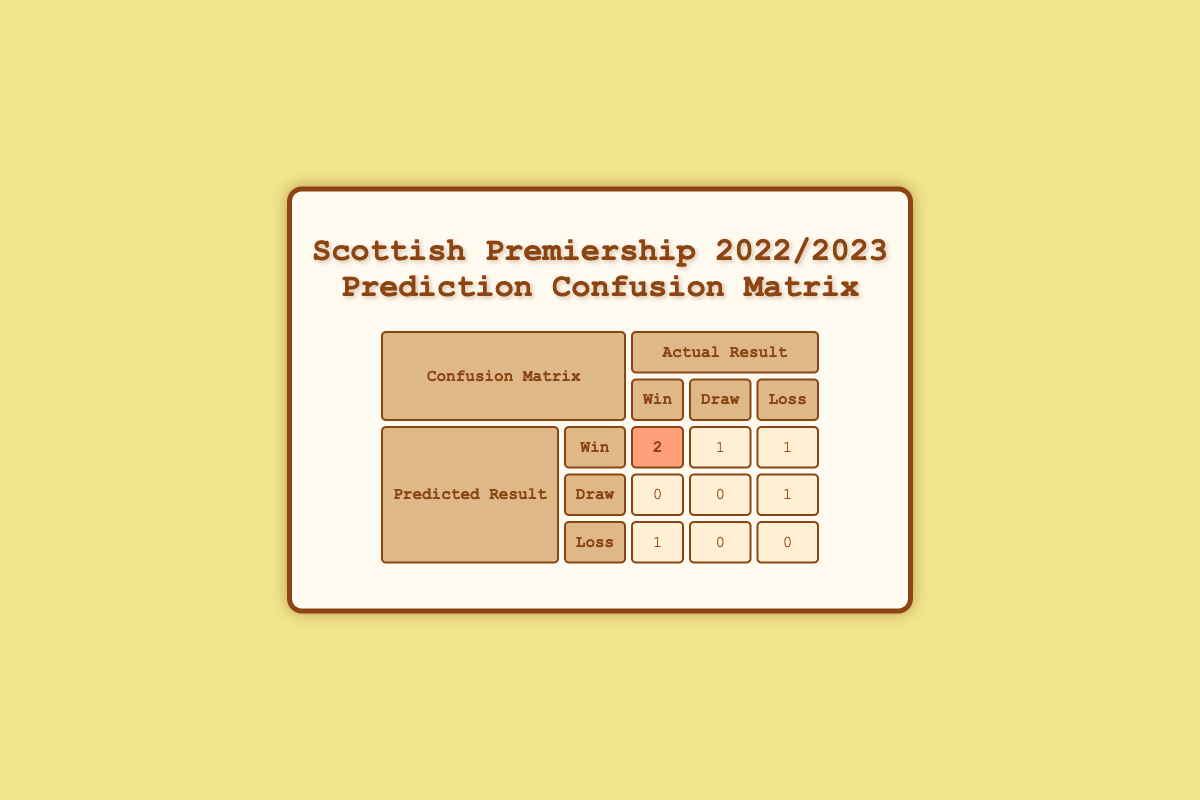What is the predicted result when the actual result was a Celtic Win? In the table, for the match "Celtic vs Rangers," both the predicted result and actual result are "Celtic Win." Therefore, the predicted result in this case is Celtic Win.
Answer: Celtic Win How many matches were predicted to have a Win? The table shows two matches where the predicted result was a Win: "Celtic vs Rangers" and "Aberdeen vs Dundee United." Therefore, there are 2 matches predicted to be a Win.
Answer: 2 What is the total number of matches that ended in a Win according to the actual results? From the table, there are 3 actual wins: "Celtic Win," "Aberdeen Win," and "St Mirren Win." Adding them together gives 3 matches that ended in a Win.
Answer: 3 Is there any match where the predicted result was a Draw and the actual result was also a Draw? In the table, there is no match where the predicted result was a Draw and the actual result was a Draw. The relevant entries show a predicted Draw for "Kilmarnock vs Ross County" and the actual result was a Draw but not a match where predicted and actual draw match.
Answer: No How many predicted Wins were actually Losses? Looking closely, the only match classified as a predicted Loss is "Motherwell vs St Mirren," which resulted in a St Mirren Win. Thus, there was 1 instance where a predicted Win was actually a Loss.
Answer: 1 If we consider only the predicted Draws, what is their total count? The table lists one prediction for Draw: "Kilmarnock vs Ross County." Therefore, the total number of predicted Draws is 1.
Answer: 1 What proportion of the predicted Wins turned out to be actual Wins? Out of 3 matches predicted to result in Wins, 2 resulted in actual Wins. Therefore, the proportion is 2 out of 3, which can be expressed as 2/3 or approximately 66.7%.
Answer: 66.7% Which category has the highest predicted outcome based on the table? The category with the highest predicted outcome is "Win," which has a total of 3 matches predicted as Wins.
Answer: Win What is the total number of matches across all predicted outcomes? The total number of matches recorded in the table is 6: "Celtic vs Rangers," "Hearts vs Hibernian," "Aberdeen vs Dundee United," "St Johnstone vs Livingston," "Kilmarnock vs Ross County," and "Motherwell vs St Mirren."
Answer: 6 